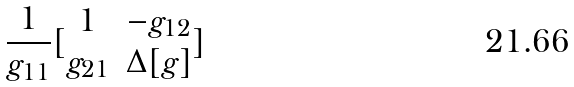<formula> <loc_0><loc_0><loc_500><loc_500>\frac { 1 } { g _ { 1 1 } } [ \begin{matrix} 1 & - g _ { 1 2 } \\ g _ { 2 1 } & \Delta [ g ] \end{matrix} ]</formula> 